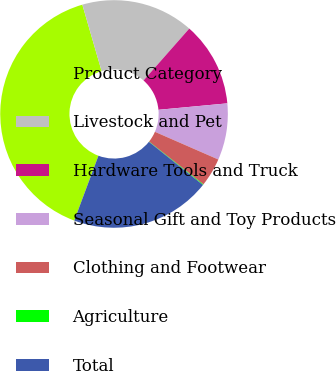<chart> <loc_0><loc_0><loc_500><loc_500><pie_chart><fcel>Product Category<fcel>Livestock and Pet<fcel>Hardware Tools and Truck<fcel>Seasonal Gift and Toy Products<fcel>Clothing and Footwear<fcel>Agriculture<fcel>Total<nl><fcel>39.82%<fcel>15.99%<fcel>12.02%<fcel>8.04%<fcel>4.07%<fcel>0.1%<fcel>19.96%<nl></chart> 